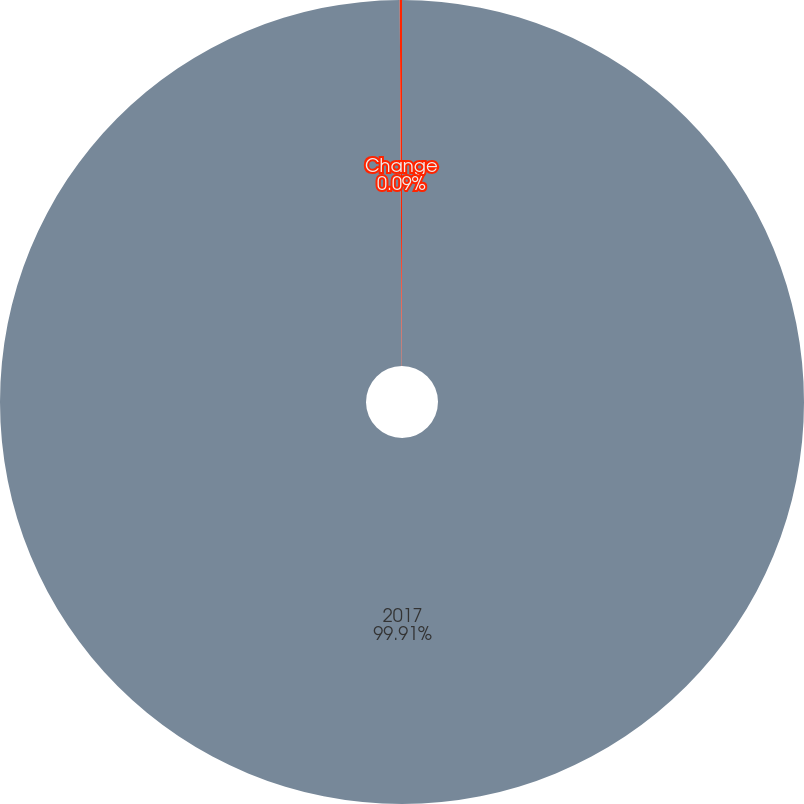Convert chart to OTSL. <chart><loc_0><loc_0><loc_500><loc_500><pie_chart><fcel>2017<fcel>Change<nl><fcel>99.91%<fcel>0.09%<nl></chart> 